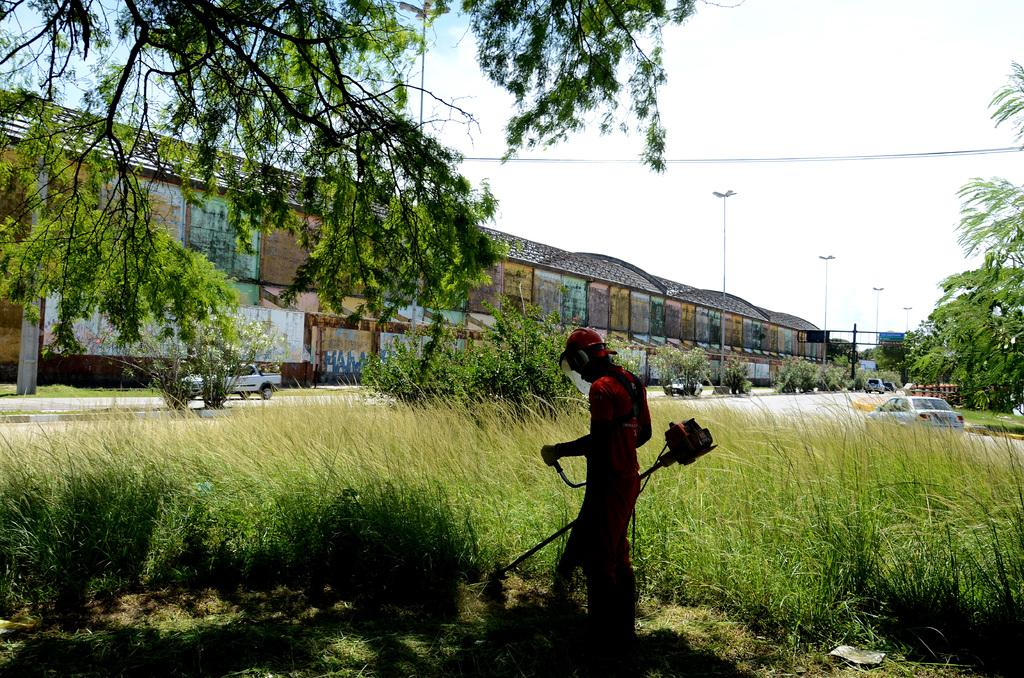What is the person in the image doing? The person is standing and holding an object in the image. What type of natural elements can be seen in the image? There are trees and plants in the image. What type of man-made structures are present in the image? There is a building and street lights in the image. What type of transportation is visible in the image? There are vehicles on the road in the image. What part of the natural environment is visible in the background of the image? The sky is visible in the background of the image. How many daughters can be seen in the image? There are no daughters present in the image. 